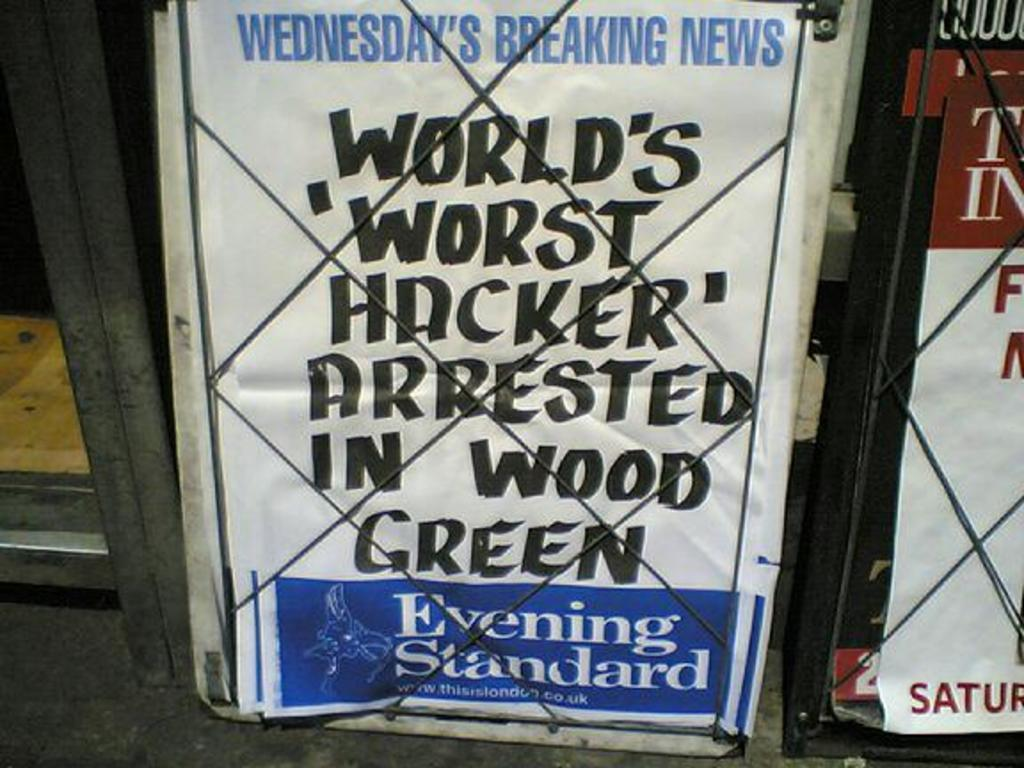<image>
Describe the image concisely. A newspaper promises to bring readers today's breaking news. 